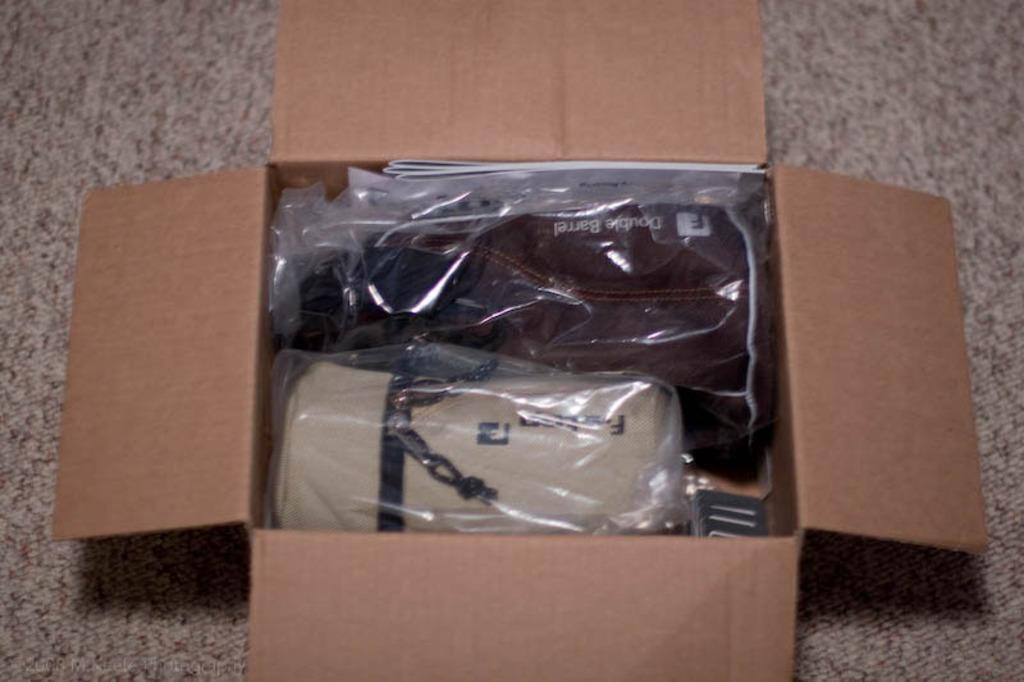What is the main object in the image? There is a box in the image. What is inside the box? The box contains books and other objects. Where is the box located? The box is placed on a platform. What type of prison is depicted in the image? There is no prison present in the image; it features a box containing books and other objects placed on a platform. 